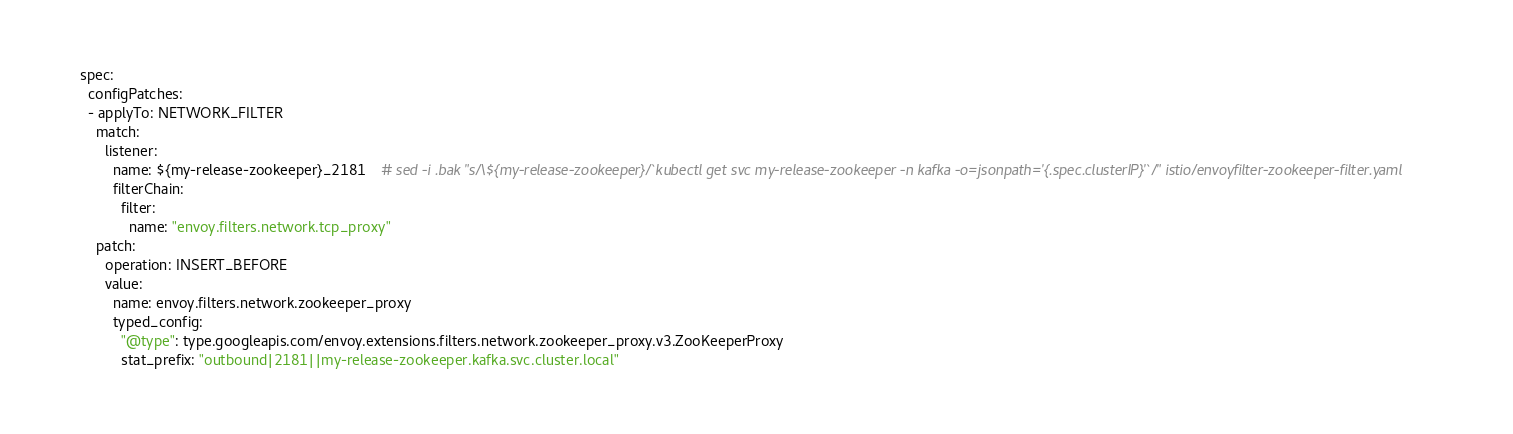<code> <loc_0><loc_0><loc_500><loc_500><_YAML_>spec:
  configPatches:
  - applyTo: NETWORK_FILTER
    match:
      listener:
        name: ${my-release-zookeeper}_2181    # sed -i .bak "s/\${my-release-zookeeper}/`kubectl get svc my-release-zookeeper -n kafka -o=jsonpath='{.spec.clusterIP}'`/" istio/envoyfilter-zookeeper-filter.yaml
        filterChain:
          filter:
            name: "envoy.filters.network.tcp_proxy"
    patch:
      operation: INSERT_BEFORE
      value:
        name: envoy.filters.network.zookeeper_proxy
        typed_config:
          "@type": type.googleapis.com/envoy.extensions.filters.network.zookeeper_proxy.v3.ZooKeeperProxy
          stat_prefix: "outbound|2181||my-release-zookeeper.kafka.svc.cluster.local"
</code> 